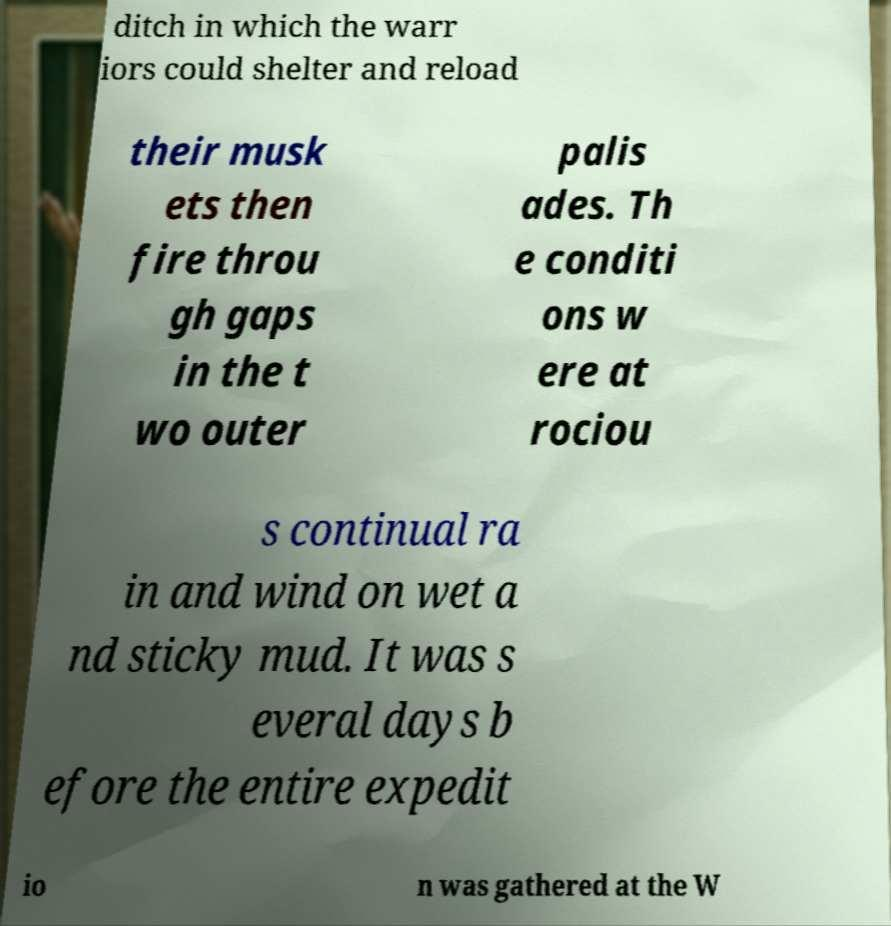Can you accurately transcribe the text from the provided image for me? ditch in which the warr iors could shelter and reload their musk ets then fire throu gh gaps in the t wo outer palis ades. Th e conditi ons w ere at rociou s continual ra in and wind on wet a nd sticky mud. It was s everal days b efore the entire expedit io n was gathered at the W 